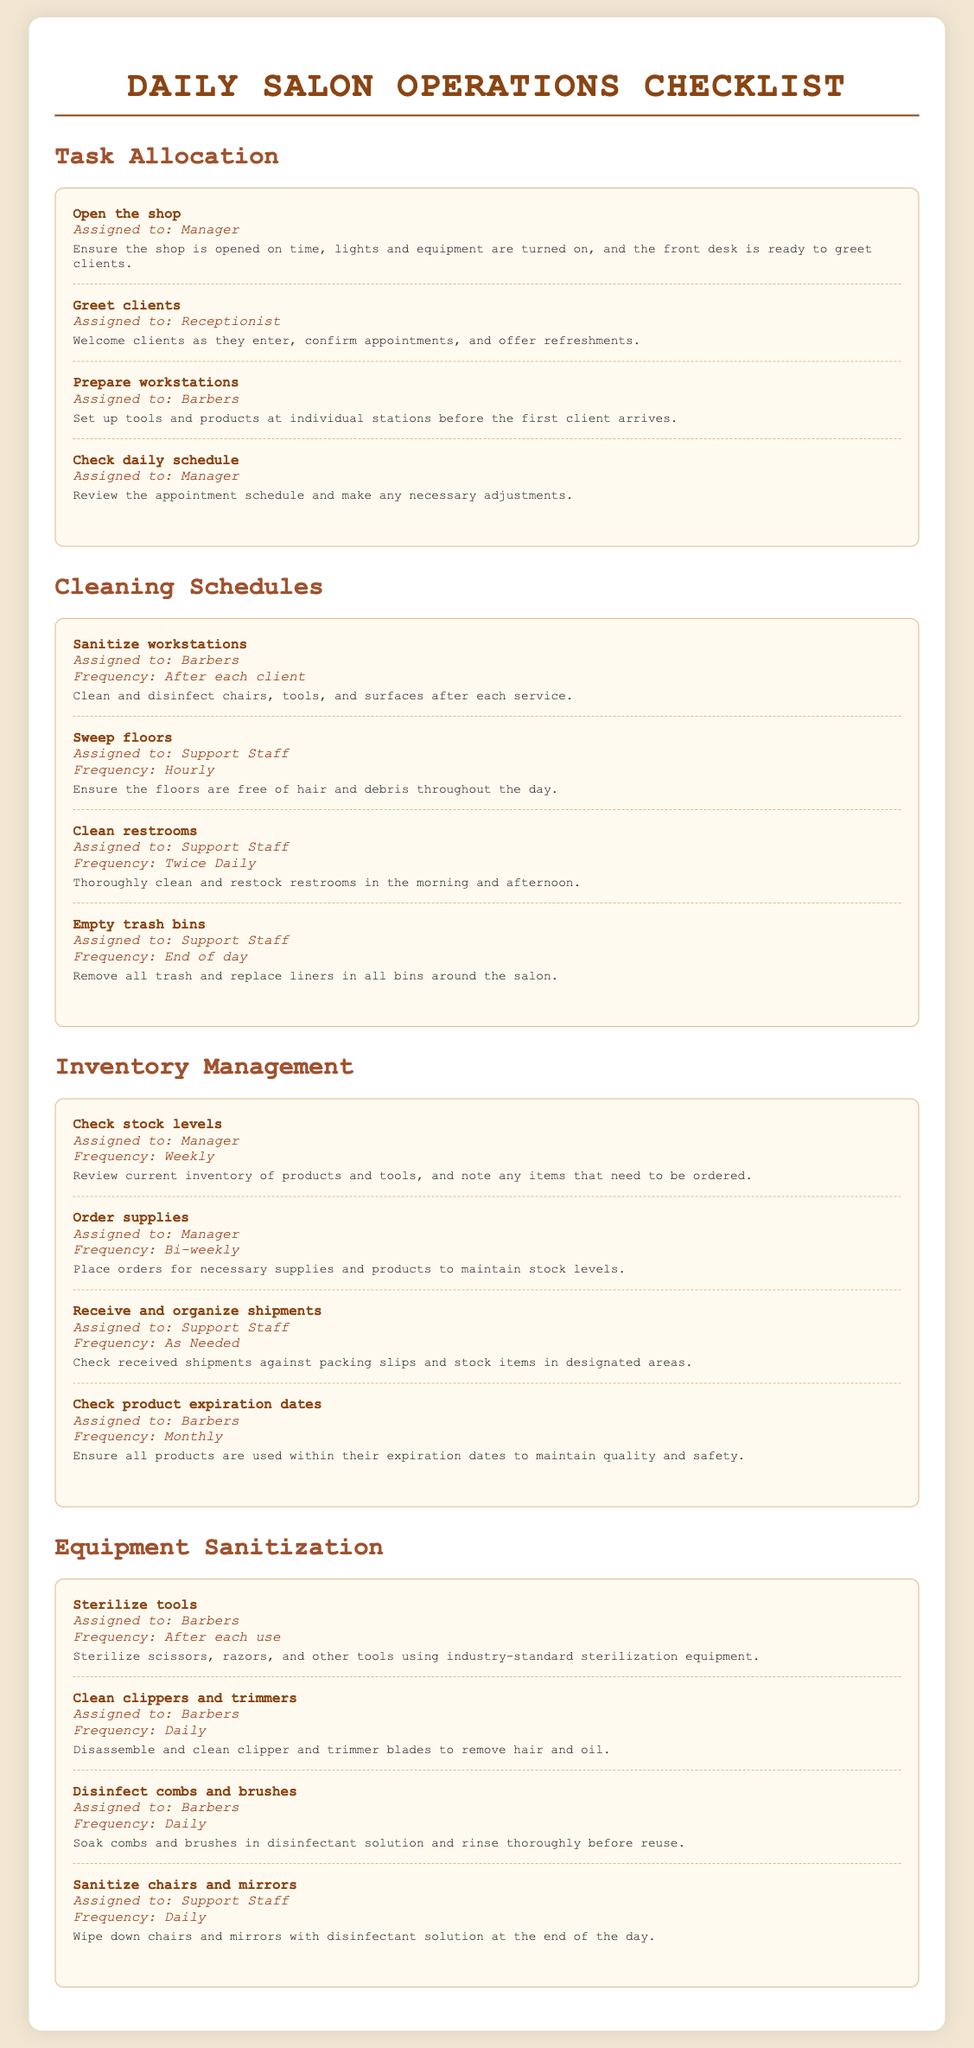what is the task for the manager in the task allocation section? The task for the manager is to open the shop and check the daily schedule.
Answer: Open the shop, Check daily schedule who is responsible for sanitizing workstations? Barbers are assigned to sanitize workstations after each client.
Answer: Barbers how often should the restrooms be cleaned? The restrooms should be cleaned twice daily according to the cleaning schedule.
Answer: Twice Daily what is the frequency for checking stock levels? The frequency for checking stock levels is weekly as stated in the inventory management section.
Answer: Weekly which staff is responsible for sterilizing tools? Barbers are responsible for sterilizing tools after each use.
Answer: Barbers how often should clipper and trimmer blades be cleaned? The clipper and trimmer blades should be cleaned daily.
Answer: Daily which task has a responsibility assigned to the support staff in the cleaning schedules? The support staff are responsible for sweeping floors, cleaning restrooms, and emptying trash bins.
Answer: Sweep floors, Clean restrooms, Empty trash bins what type of items should be checked for expiration monthly? Barbers are responsible for checking product expiration dates monthly.
Answer: Products what cleaning task is performed at the end of the day? The task of sanitizing chairs and mirrors is performed at the end of the day.
Answer: Sanitize chairs and mirrors 